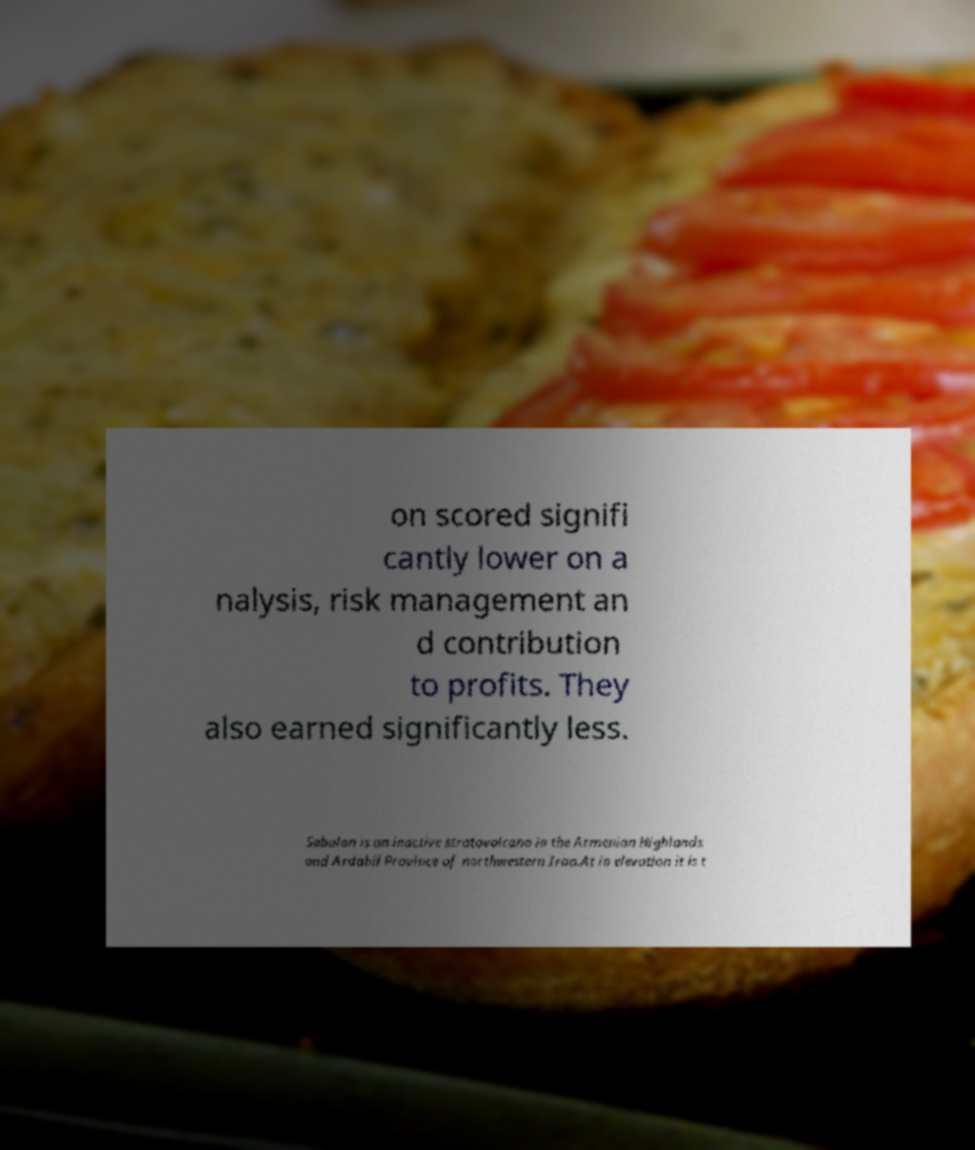For documentation purposes, I need the text within this image transcribed. Could you provide that? on scored signifi cantly lower on a nalysis, risk management an d contribution to profits. They also earned significantly less. Sabalan is an inactive stratovolcano in the Armenian Highlands and Ardabil Province of northwestern Iran.At in elevation it is t 